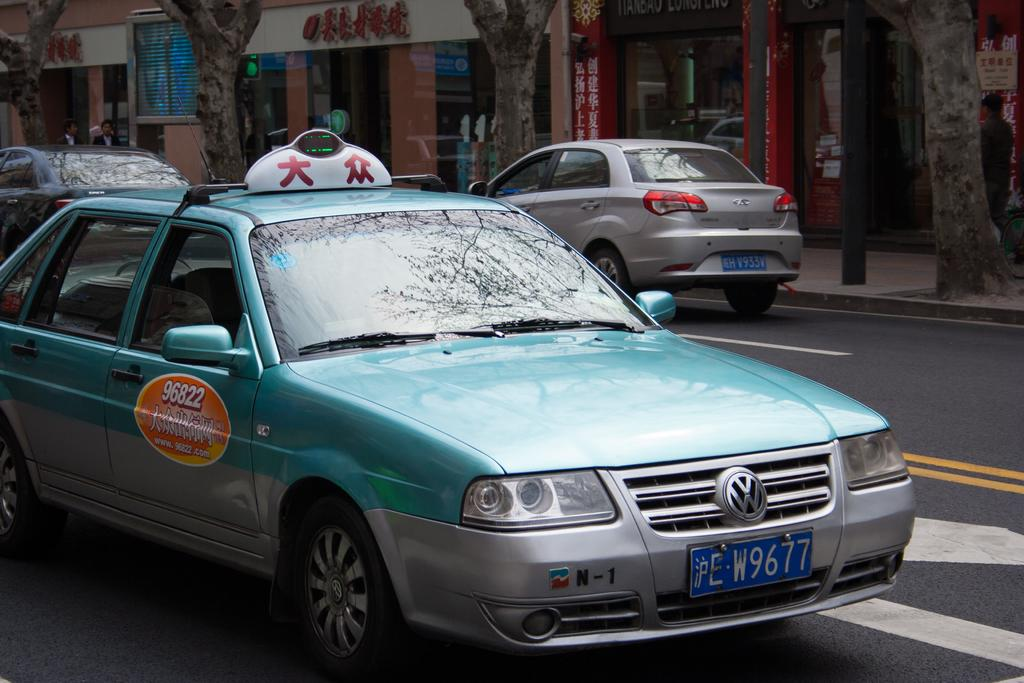<image>
Summarize the visual content of the image. An Asian cab with the license plate E W677. 